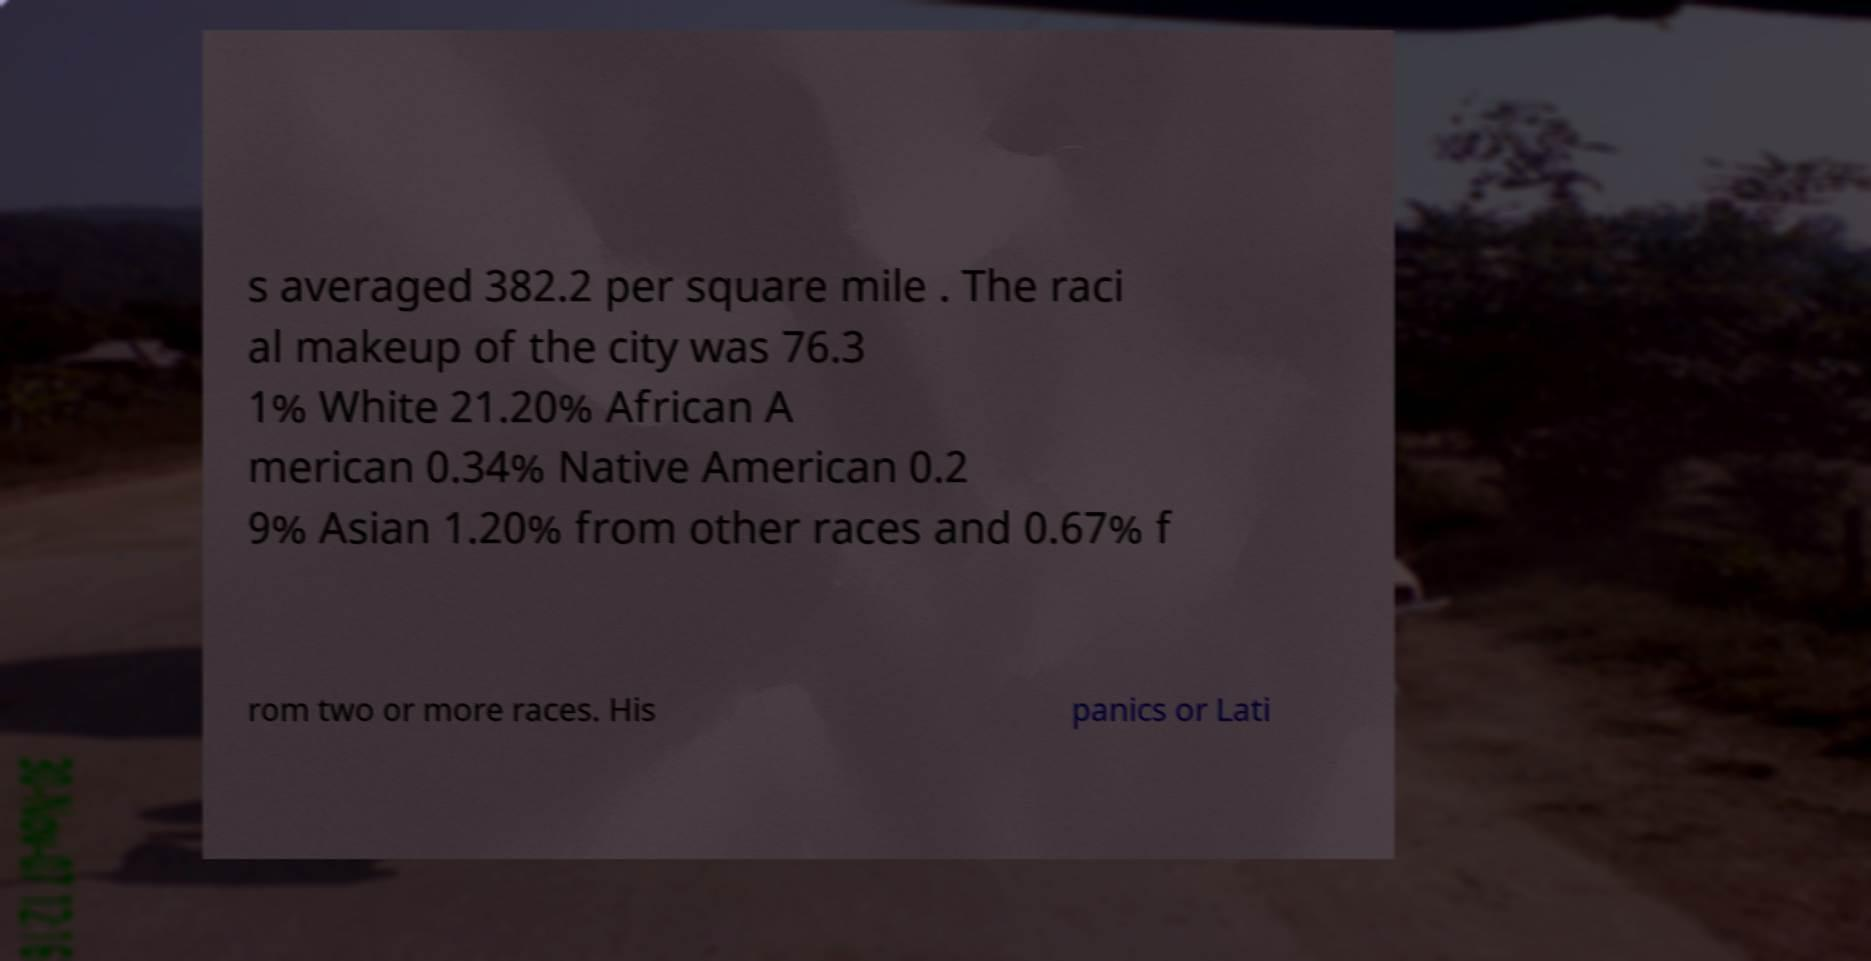Can you accurately transcribe the text from the provided image for me? s averaged 382.2 per square mile . The raci al makeup of the city was 76.3 1% White 21.20% African A merican 0.34% Native American 0.2 9% Asian 1.20% from other races and 0.67% f rom two or more races. His panics or Lati 